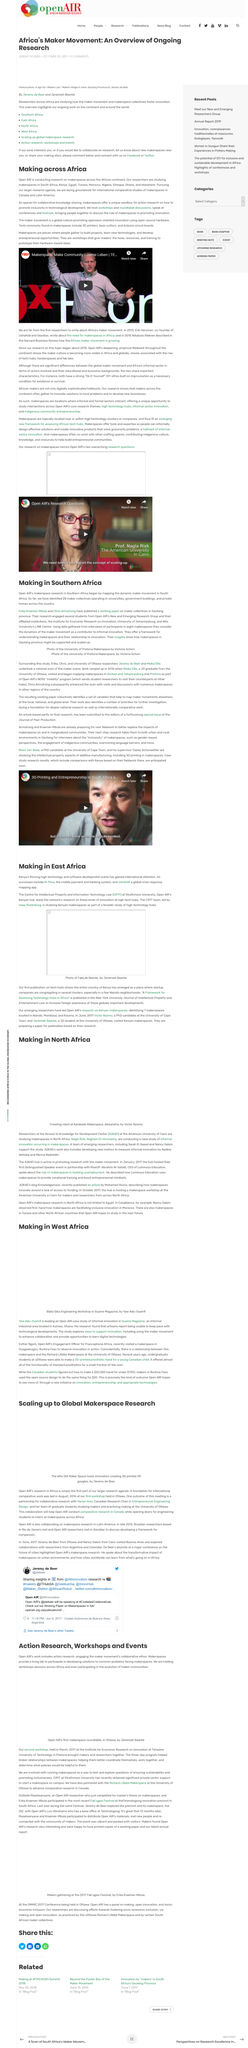Indicate a few pertinent items in this graphic. Open AIR is conducting research on makerspaces across the African continent, with a specific focus on the impact and potential of these spaces in promoting innovation, entrepreneurship, and sustainable development. Open AIR is laying the groundwork for international comparative studies of makerspaces, with a focus on Canada and Latin America. A total of 28 maker collectives, operating in universities, government buildings, and private homes across South Africa, have been identified. M-Pesa, a mobile money transfer service, was developed in Kenya, and the CIPT team is currently studying it. Strathmore University is the institution that houses the Centre for Intellectual Property and Information Technology Law. 